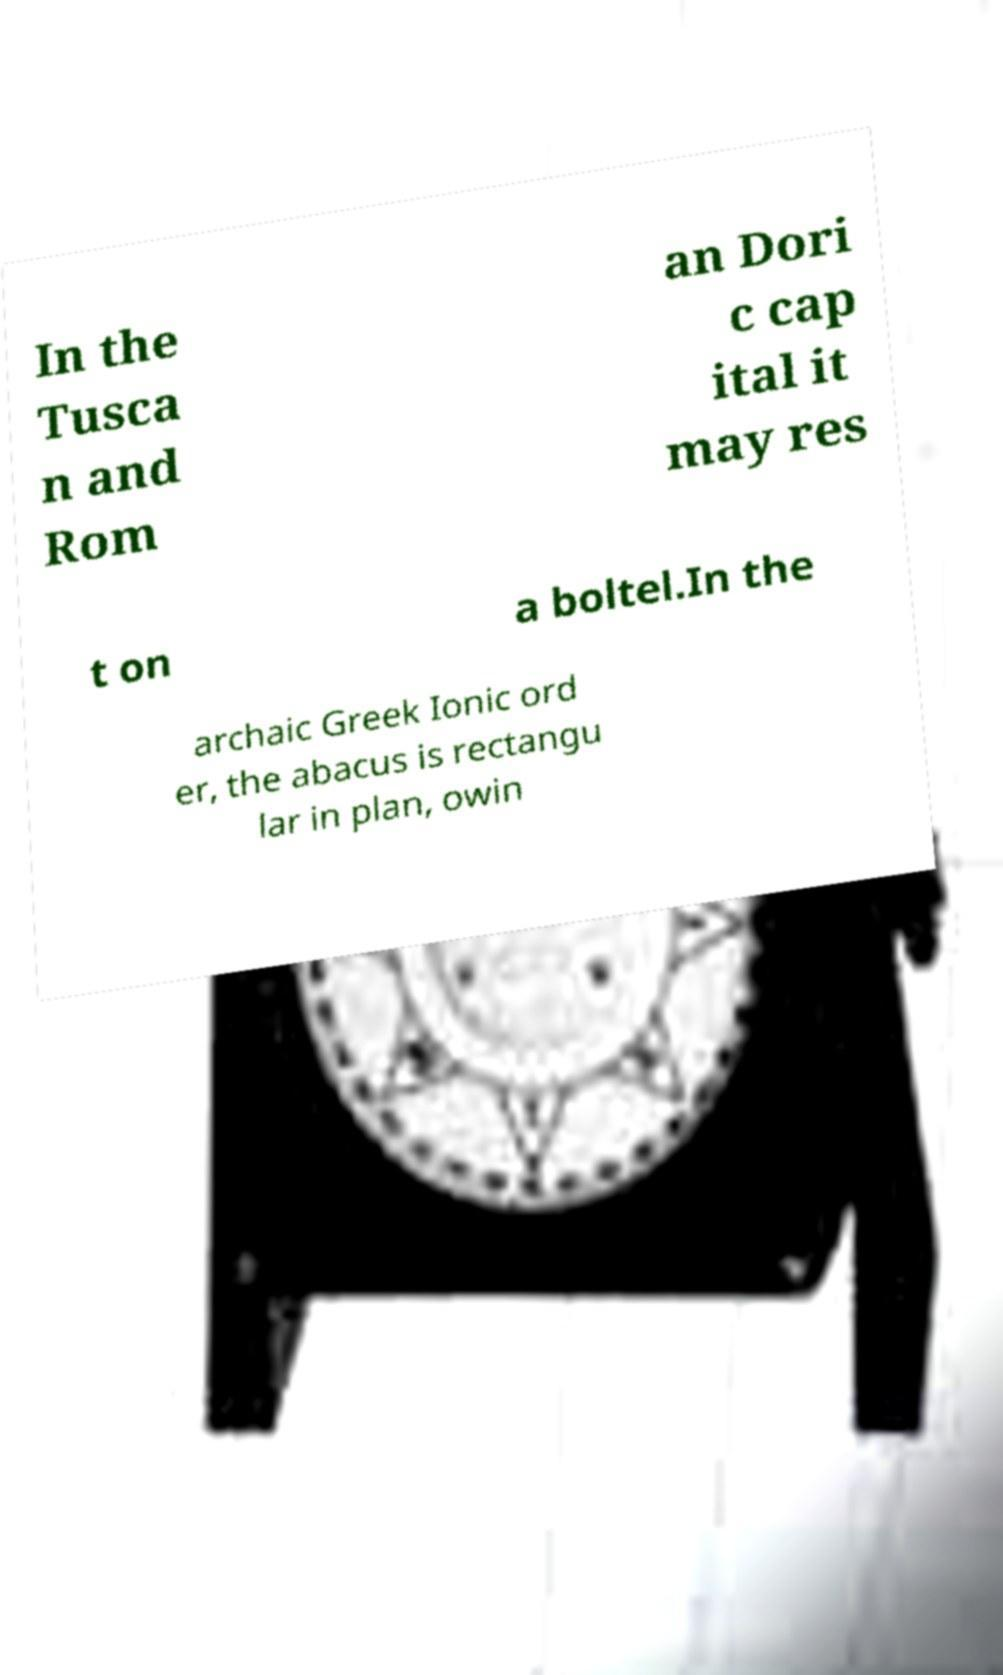What messages or text are displayed in this image? I need them in a readable, typed format. In the Tusca n and Rom an Dori c cap ital it may res t on a boltel.In the archaic Greek Ionic ord er, the abacus is rectangu lar in plan, owin 